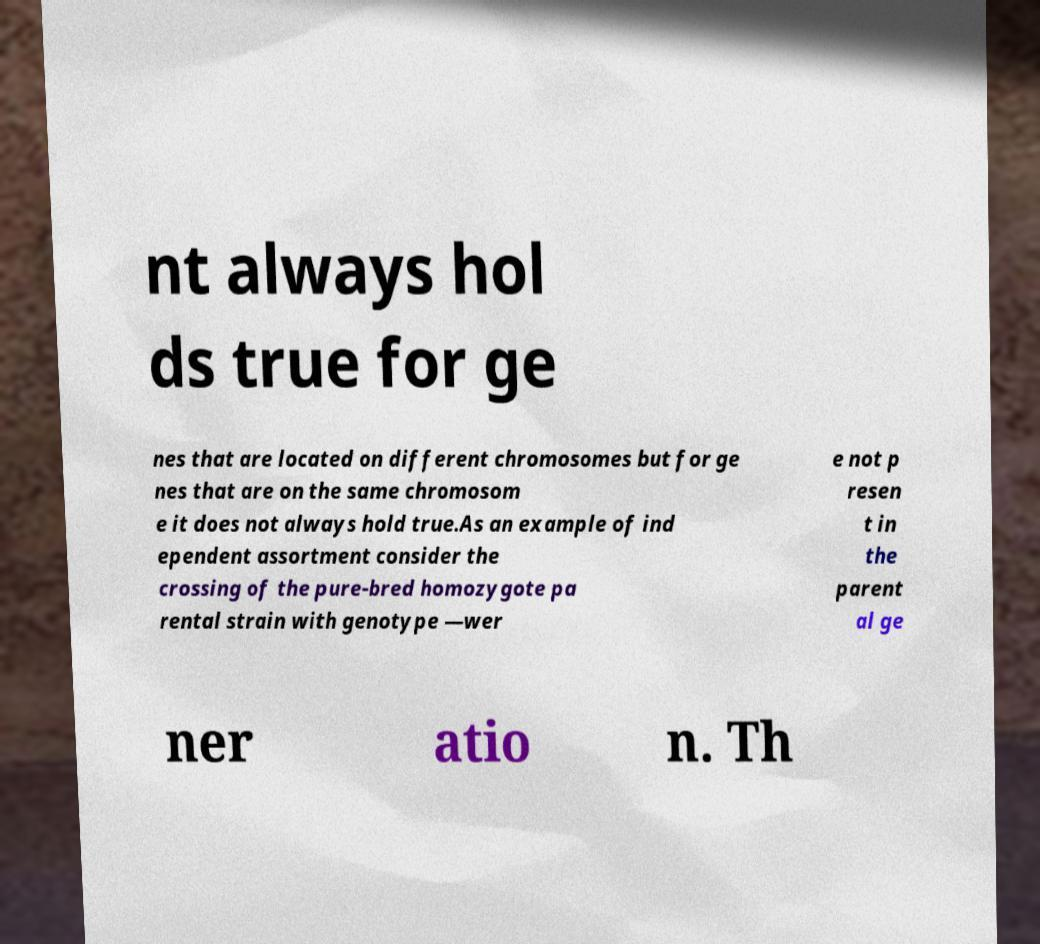Could you extract and type out the text from this image? nt always hol ds true for ge nes that are located on different chromosomes but for ge nes that are on the same chromosom e it does not always hold true.As an example of ind ependent assortment consider the crossing of the pure-bred homozygote pa rental strain with genotype —wer e not p resen t in the parent al ge ner atio n. Th 